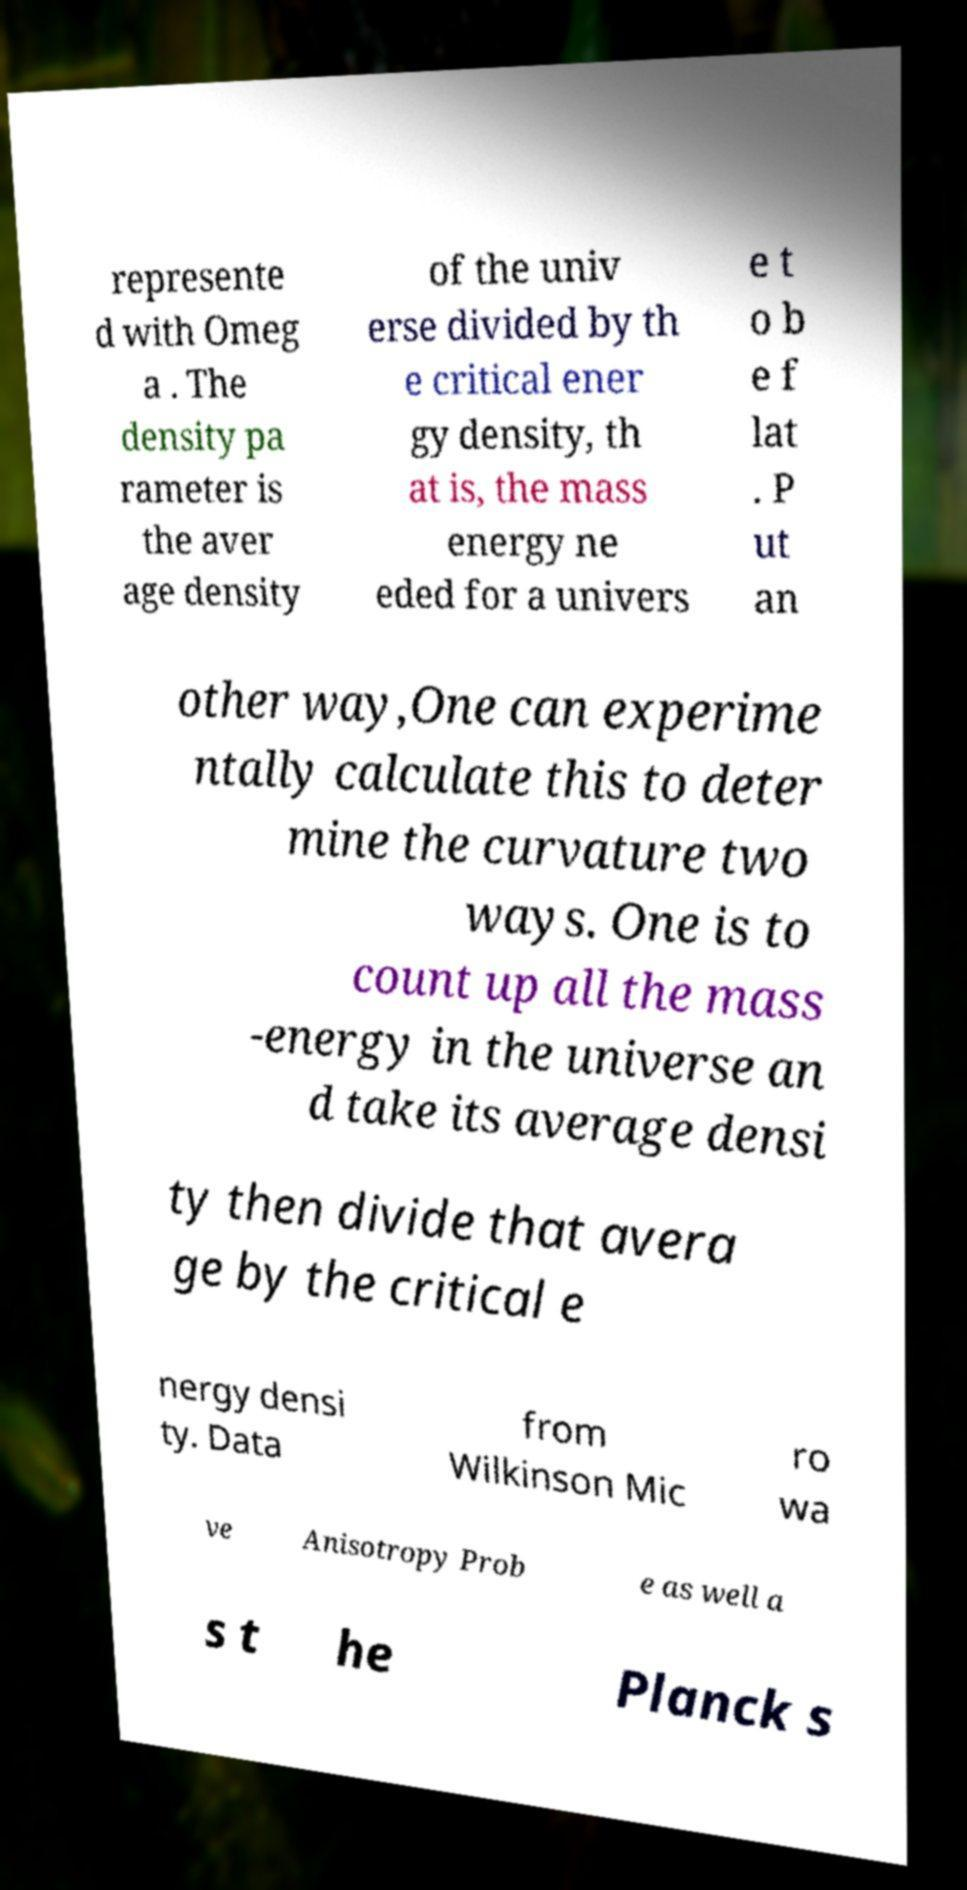Could you assist in decoding the text presented in this image and type it out clearly? represente d with Omeg a . The density pa rameter is the aver age density of the univ erse divided by th e critical ener gy density, th at is, the mass energy ne eded for a univers e t o b e f lat . P ut an other way,One can experime ntally calculate this to deter mine the curvature two ways. One is to count up all the mass -energy in the universe an d take its average densi ty then divide that avera ge by the critical e nergy densi ty. Data from Wilkinson Mic ro wa ve Anisotropy Prob e as well a s t he Planck s 